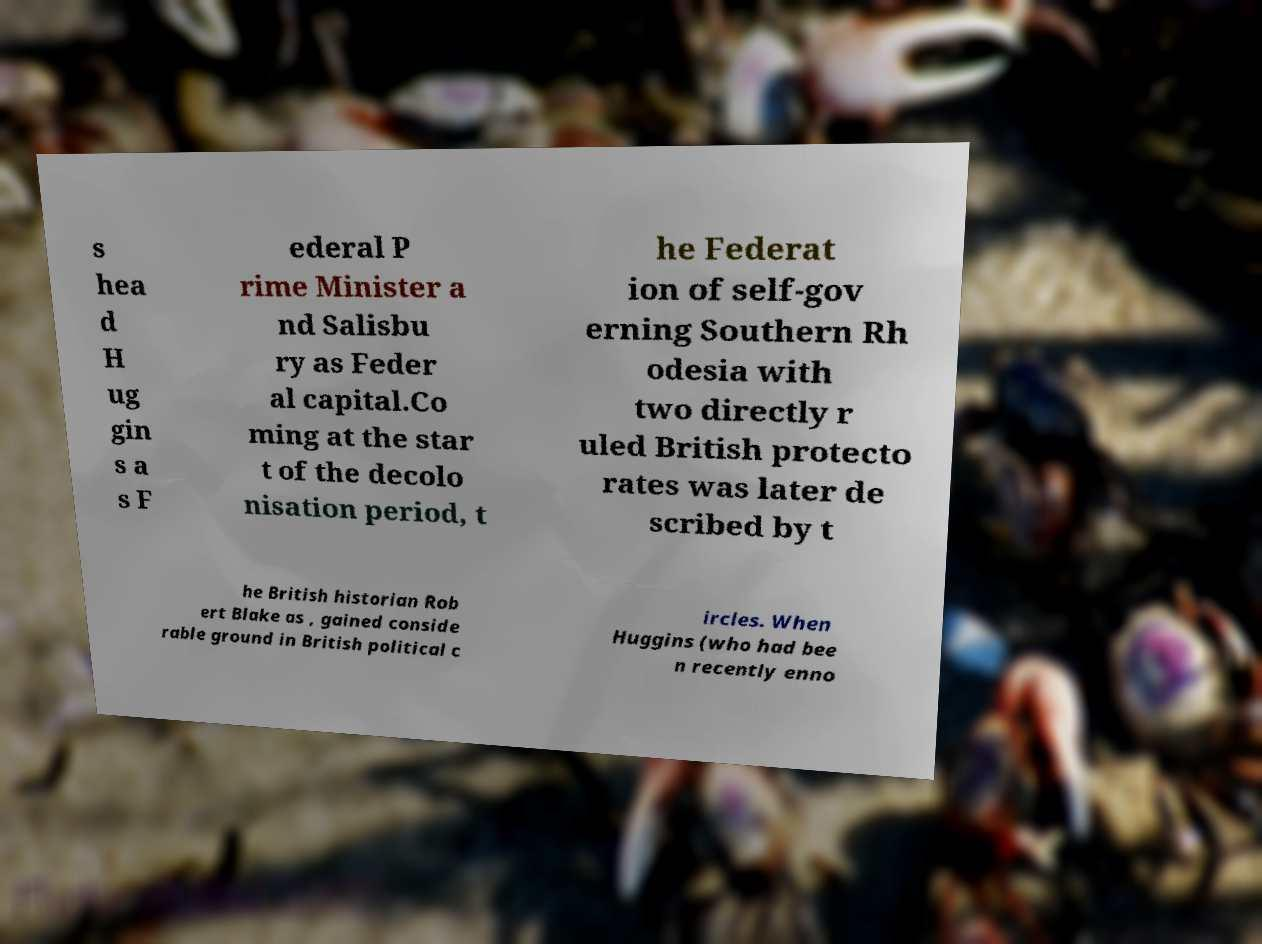Please read and relay the text visible in this image. What does it say? s hea d H ug gin s a s F ederal P rime Minister a nd Salisbu ry as Feder al capital.Co ming at the star t of the decolo nisation period, t he Federat ion of self-gov erning Southern Rh odesia with two directly r uled British protecto rates was later de scribed by t he British historian Rob ert Blake as , gained conside rable ground in British political c ircles. When Huggins (who had bee n recently enno 